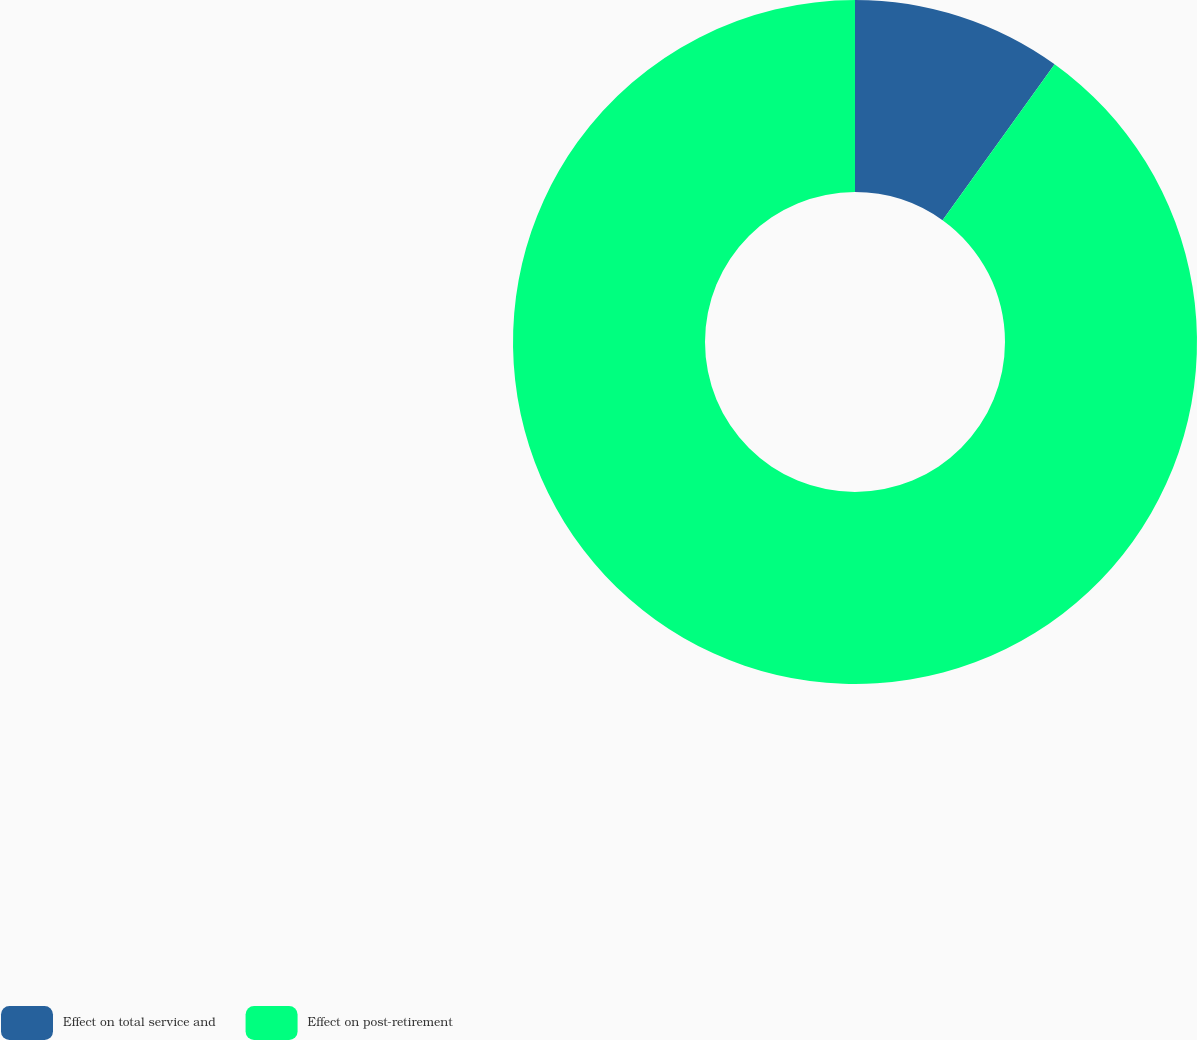<chart> <loc_0><loc_0><loc_500><loc_500><pie_chart><fcel>Effect on total service and<fcel>Effect on post-retirement<nl><fcel>9.92%<fcel>90.08%<nl></chart> 